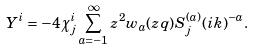Convert formula to latex. <formula><loc_0><loc_0><loc_500><loc_500>Y ^ { i } = - 4 \chi ^ { i } _ { j } \sum _ { a = - 1 } ^ { \infty } z ^ { 2 } w _ { a } ( z q ) S _ { j } ^ { ( a ) } ( i k ) ^ { - a } .</formula> 